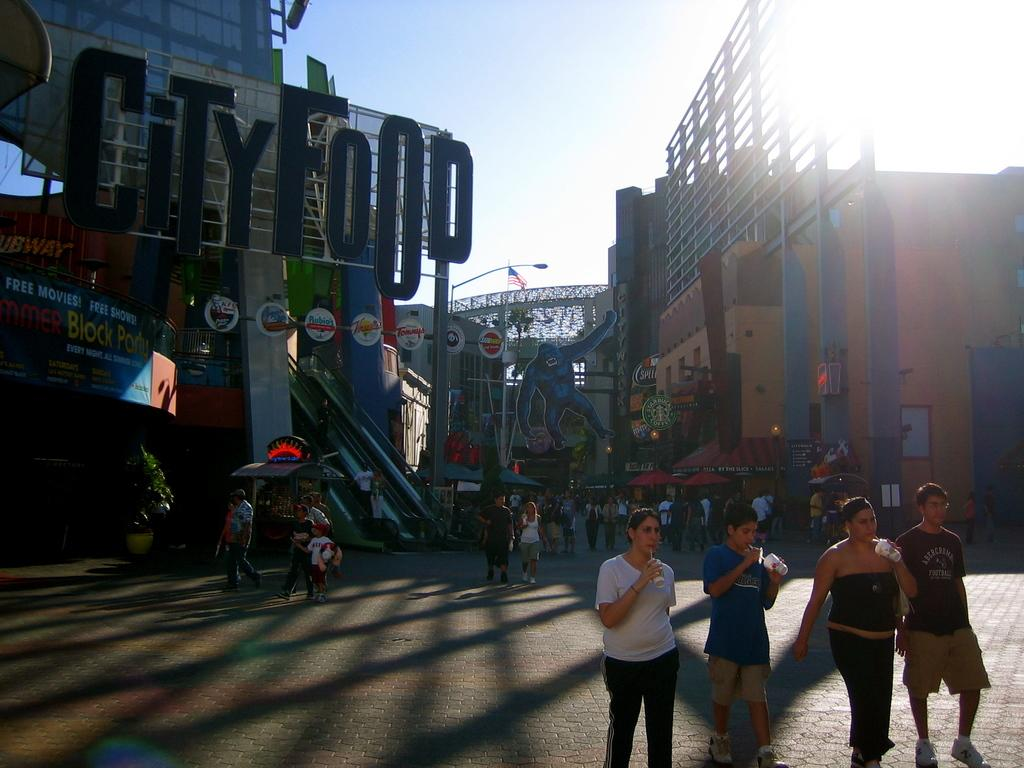What type of structures can be seen in the image? There are buildings in the image. Who or what else is present in the image? There are people and boards visible in the image. What architectural feature is present in the image? There is a bridge in the image. What can be seen in the background of the image? The sky is visible in the background of the image. What type of record is being played by the doctor in the image? There is no record or doctor present in the image. What is the sister doing in the image? There is no sister present in the image. 